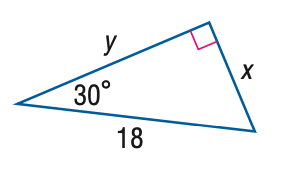Answer the mathemtical geometry problem and directly provide the correct option letter.
Question: Find x.
Choices: A: 6 B: 9 C: 10.4 D: 12.7 B 